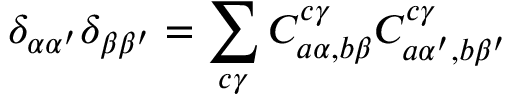Convert formula to latex. <formula><loc_0><loc_0><loc_500><loc_500>\delta _ { \alpha \alpha ^ { \prime } } \delta _ { \beta \beta ^ { \prime } } = \sum _ { c \gamma } C _ { a \alpha , b \beta } ^ { c \gamma } C _ { a \alpha ^ { \prime } , b \beta ^ { \prime } } ^ { c \gamma }</formula> 